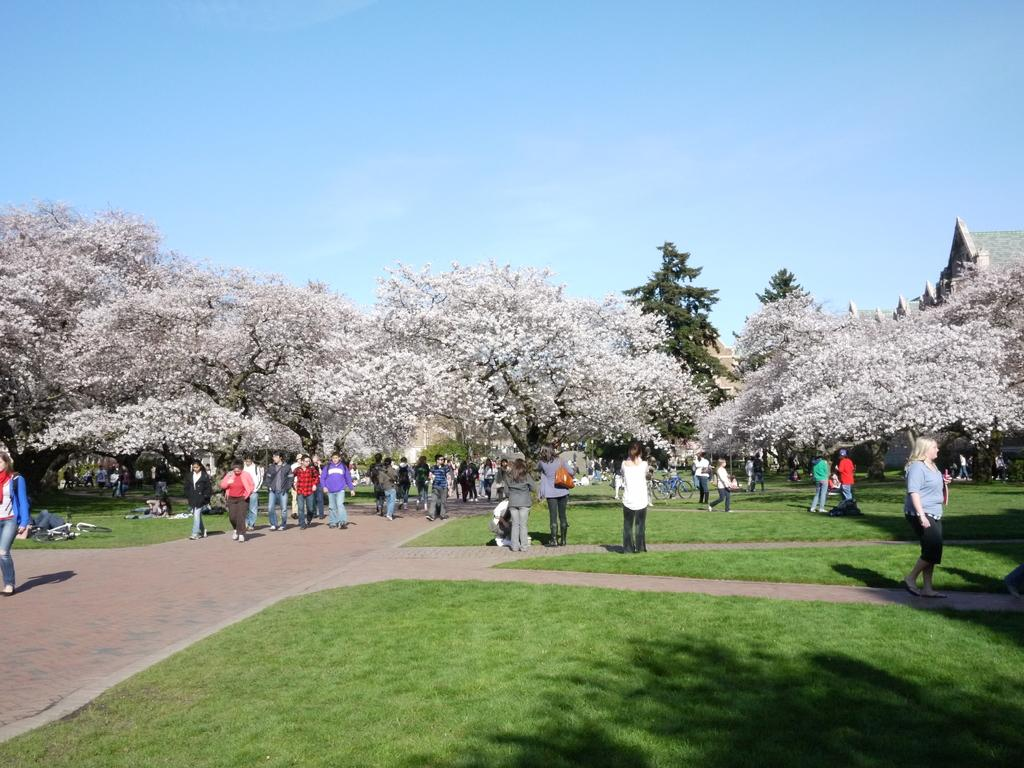What are the people in the image doing? The people in the image are walking. On what surface are the people walking? The people are walking on the ground. What type of vegetation is present on the ground? There is grass on the ground. What can be seen in the background of the image? There are trees and houses in the background of the image. What is visible at the top of the image? The sky is visible at the top of the image. What type of cup is being used to wash the trees in the image? There is no cup or washing activity present in the image. The people are walking, and there are trees in the background. 